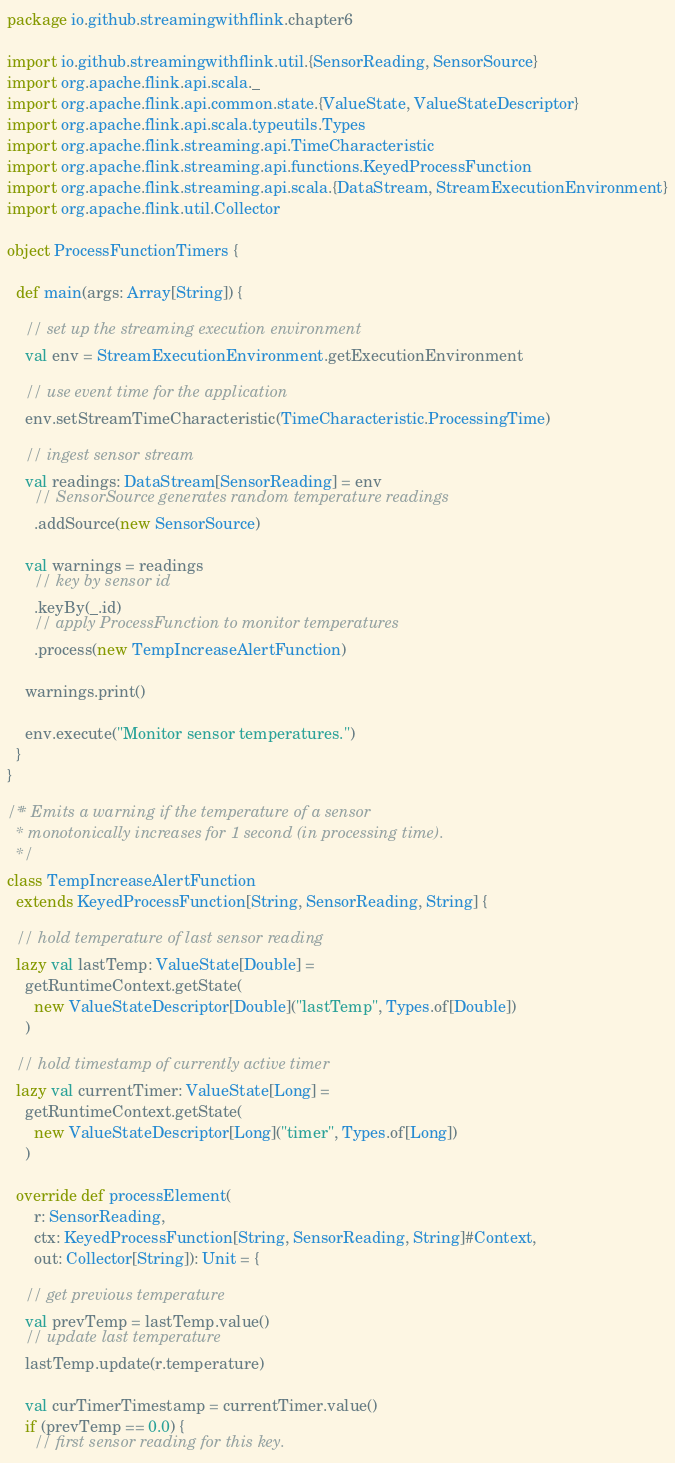<code> <loc_0><loc_0><loc_500><loc_500><_Scala_>package io.github.streamingwithflink.chapter6

import io.github.streamingwithflink.util.{SensorReading, SensorSource}
import org.apache.flink.api.scala._
import org.apache.flink.api.common.state.{ValueState, ValueStateDescriptor}
import org.apache.flink.api.scala.typeutils.Types
import org.apache.flink.streaming.api.TimeCharacteristic
import org.apache.flink.streaming.api.functions.KeyedProcessFunction
import org.apache.flink.streaming.api.scala.{DataStream, StreamExecutionEnvironment}
import org.apache.flink.util.Collector

object ProcessFunctionTimers {

  def main(args: Array[String]) {

    // set up the streaming execution environment
    val env = StreamExecutionEnvironment.getExecutionEnvironment

    // use event time for the application
    env.setStreamTimeCharacteristic(TimeCharacteristic.ProcessingTime)

    // ingest sensor stream
    val readings: DataStream[SensorReading] = env
      // SensorSource generates random temperature readings
      .addSource(new SensorSource)

    val warnings = readings
      // key by sensor id
      .keyBy(_.id)
      // apply ProcessFunction to monitor temperatures
      .process(new TempIncreaseAlertFunction)

    warnings.print()

    env.execute("Monitor sensor temperatures.")
  }
}

/** Emits a warning if the temperature of a sensor
  * monotonically increases for 1 second (in processing time).
  */
class TempIncreaseAlertFunction
  extends KeyedProcessFunction[String, SensorReading, String] {

  // hold temperature of last sensor reading
  lazy val lastTemp: ValueState[Double] =
    getRuntimeContext.getState(
      new ValueStateDescriptor[Double]("lastTemp", Types.of[Double])
    )

  // hold timestamp of currently active timer
  lazy val currentTimer: ValueState[Long] =
    getRuntimeContext.getState(
      new ValueStateDescriptor[Long]("timer", Types.of[Long])
    )

  override def processElement(
      r: SensorReading,
      ctx: KeyedProcessFunction[String, SensorReading, String]#Context,
      out: Collector[String]): Unit = {

    // get previous temperature
    val prevTemp = lastTemp.value()
    // update last temperature
    lastTemp.update(r.temperature)

    val curTimerTimestamp = currentTimer.value()
    if (prevTemp == 0.0) {
      // first sensor reading for this key.</code> 